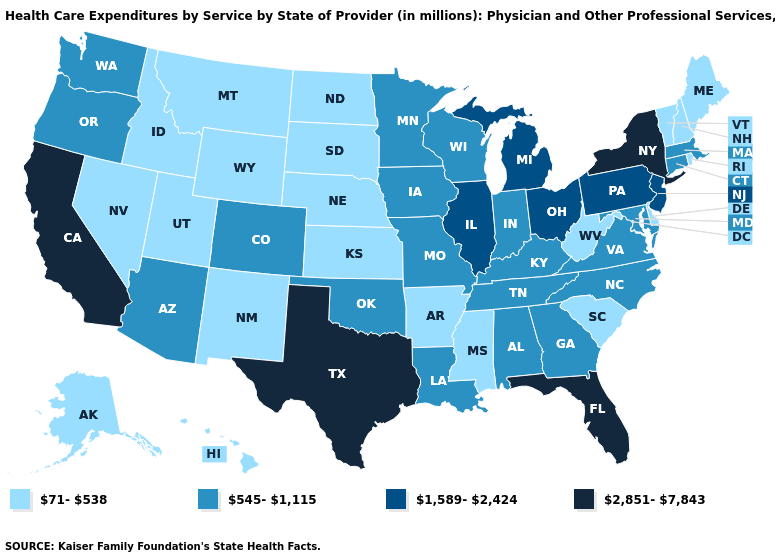Does Mississippi have the lowest value in the South?
Keep it brief. Yes. Which states have the lowest value in the South?
Be succinct. Arkansas, Delaware, Mississippi, South Carolina, West Virginia. Name the states that have a value in the range 545-1,115?
Write a very short answer. Alabama, Arizona, Colorado, Connecticut, Georgia, Indiana, Iowa, Kentucky, Louisiana, Maryland, Massachusetts, Minnesota, Missouri, North Carolina, Oklahoma, Oregon, Tennessee, Virginia, Washington, Wisconsin. Among the states that border New Mexico , does Oklahoma have the highest value?
Answer briefly. No. Which states have the lowest value in the South?
Answer briefly. Arkansas, Delaware, Mississippi, South Carolina, West Virginia. What is the value of Kentucky?
Concise answer only. 545-1,115. What is the lowest value in the MidWest?
Give a very brief answer. 71-538. Name the states that have a value in the range 71-538?
Give a very brief answer. Alaska, Arkansas, Delaware, Hawaii, Idaho, Kansas, Maine, Mississippi, Montana, Nebraska, Nevada, New Hampshire, New Mexico, North Dakota, Rhode Island, South Carolina, South Dakota, Utah, Vermont, West Virginia, Wyoming. Does the map have missing data?
Give a very brief answer. No. Name the states that have a value in the range 71-538?
Be succinct. Alaska, Arkansas, Delaware, Hawaii, Idaho, Kansas, Maine, Mississippi, Montana, Nebraska, Nevada, New Hampshire, New Mexico, North Dakota, Rhode Island, South Carolina, South Dakota, Utah, Vermont, West Virginia, Wyoming. What is the value of Maine?
Give a very brief answer. 71-538. Does New York have the highest value in the USA?
Concise answer only. Yes. What is the highest value in the USA?
Give a very brief answer. 2,851-7,843. Which states have the highest value in the USA?
Give a very brief answer. California, Florida, New York, Texas. What is the value of Florida?
Write a very short answer. 2,851-7,843. 